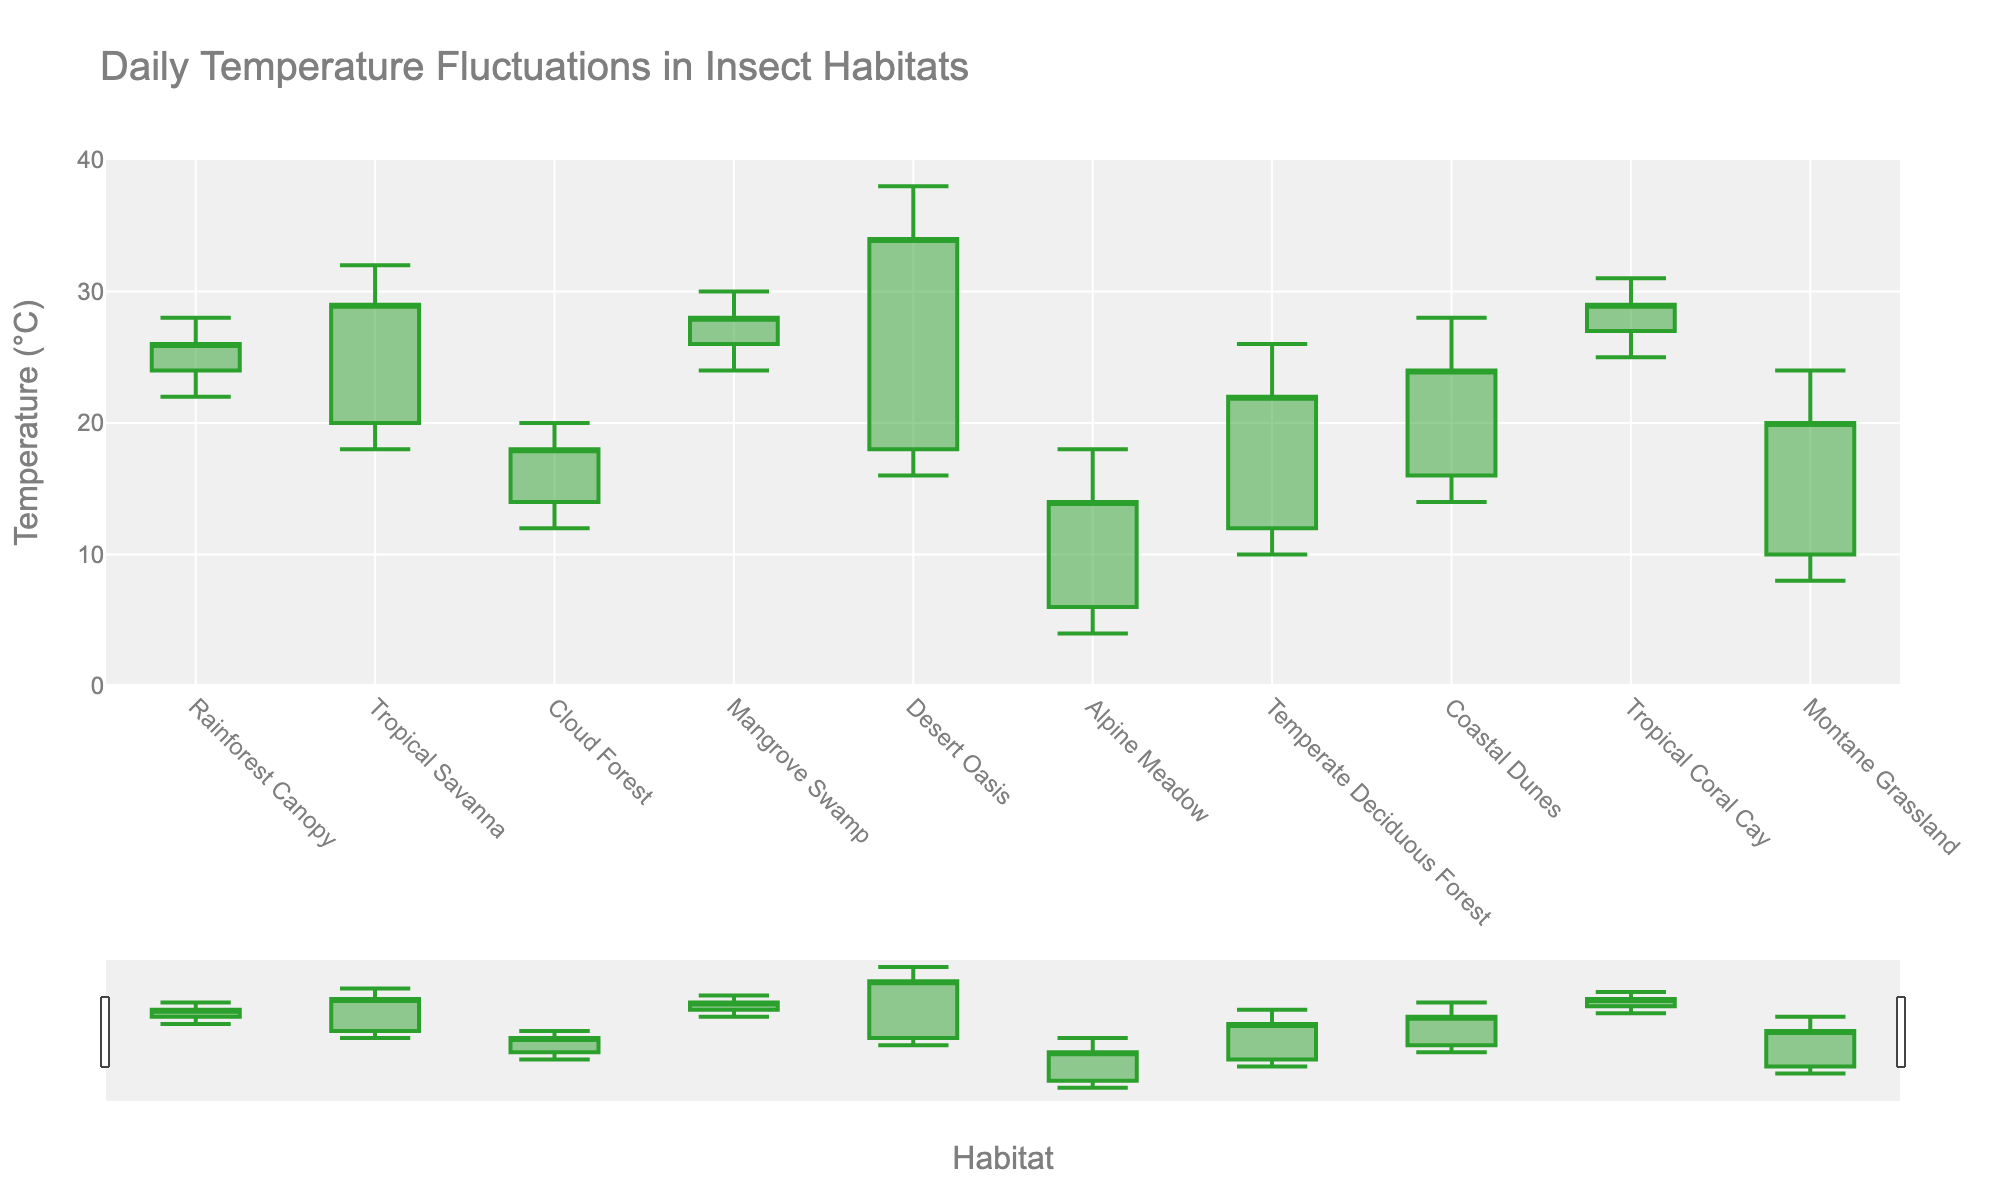What is the title of the chart? The chart's title is displayed at the top and clearly states what the figure represents.
Answer: Daily Temperature Fluctuations in Insect Habitats What is the range of the y-axis? By examining the y-axis, we can observe the minimum and maximum values labeled on it.
Answer: 0 to 40 (°C) Which habitat has the highest recorded temperature? By looking at the top end of each candlestick (the "high" value), we identify the tallest point.
Answer: Desert Oasis What is the lowest temperature recorded in the Alpine Meadow habitat? Find the lowest point of the candlestick associated with Alpine Meadow.
Answer: 4 (°C) How many habitats displayed have a high temperature above 30°C? Count all the entries where the candlestick's top (high value) is above 30°C.
Answer: 3 Which habitat has the smallest range between its high and low temperatures? Calculate the range (High - Low) for each habitat and find the smallest difference.
Answer: Cloud Forest What is the average closing temperature for Montane Grassland? Refer to the closing value for Montane Grassland.
Answer: 20 (°C) Compare the opening temperatures of Rainforest Canopy and Coastal Dunes. Which is higher? Look at the opening values for both Rainforest Canopy and Coastal Dunes and compare them.
Answer: Coastal Dunes What is the difference between the highest temperature in Tropical Savanna and Cloud Forest? Subtract the high value of Cloud Forest from the high value of Tropical Savanna.
Answer: 12 (°C) Which habitat shows the most consistent (least varying) temperatures from open to close? Identify the habitat where the distance between the open and close values (length of the body of the candlestick) is smallest.
Answer: Mangrove Swamp 